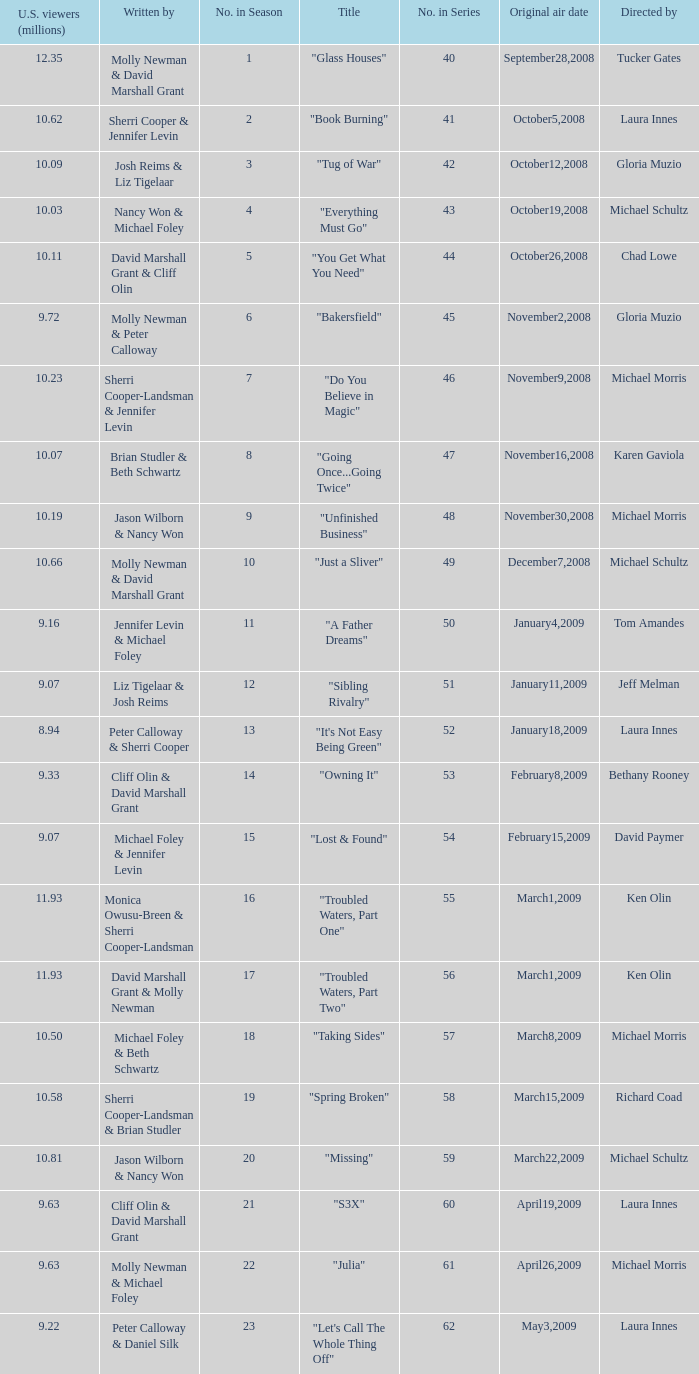Would you be able to parse every entry in this table? {'header': ['U.S. viewers (millions)', 'Written by', 'No. in Season', 'Title', 'No. in Series', 'Original air date', 'Directed by'], 'rows': [['12.35', 'Molly Newman & David Marshall Grant', '1', '"Glass Houses"', '40', 'September28,2008', 'Tucker Gates'], ['10.62', 'Sherri Cooper & Jennifer Levin', '2', '"Book Burning"', '41', 'October5,2008', 'Laura Innes'], ['10.09', 'Josh Reims & Liz Tigelaar', '3', '"Tug of War"', '42', 'October12,2008', 'Gloria Muzio'], ['10.03', 'Nancy Won & Michael Foley', '4', '"Everything Must Go"', '43', 'October19,2008', 'Michael Schultz'], ['10.11', 'David Marshall Grant & Cliff Olin', '5', '"You Get What You Need"', '44', 'October26,2008', 'Chad Lowe'], ['9.72', 'Molly Newman & Peter Calloway', '6', '"Bakersfield"', '45', 'November2,2008', 'Gloria Muzio'], ['10.23', 'Sherri Cooper-Landsman & Jennifer Levin', '7', '"Do You Believe in Magic"', '46', 'November9,2008', 'Michael Morris'], ['10.07', 'Brian Studler & Beth Schwartz', '8', '"Going Once...Going Twice"', '47', 'November16,2008', 'Karen Gaviola'], ['10.19', 'Jason Wilborn & Nancy Won', '9', '"Unfinished Business"', '48', 'November30,2008', 'Michael Morris'], ['10.66', 'Molly Newman & David Marshall Grant', '10', '"Just a Sliver"', '49', 'December7,2008', 'Michael Schultz'], ['9.16', 'Jennifer Levin & Michael Foley', '11', '"A Father Dreams"', '50', 'January4,2009', 'Tom Amandes'], ['9.07', 'Liz Tigelaar & Josh Reims', '12', '"Sibling Rivalry"', '51', 'January11,2009', 'Jeff Melman'], ['8.94', 'Peter Calloway & Sherri Cooper', '13', '"It\'s Not Easy Being Green"', '52', 'January18,2009', 'Laura Innes'], ['9.33', 'Cliff Olin & David Marshall Grant', '14', '"Owning It"', '53', 'February8,2009', 'Bethany Rooney'], ['9.07', 'Michael Foley & Jennifer Levin', '15', '"Lost & Found"', '54', 'February15,2009', 'David Paymer'], ['11.93', 'Monica Owusu-Breen & Sherri Cooper-Landsman', '16', '"Troubled Waters, Part One"', '55', 'March1,2009', 'Ken Olin'], ['11.93', 'David Marshall Grant & Molly Newman', '17', '"Troubled Waters, Part Two"', '56', 'March1,2009', 'Ken Olin'], ['10.50', 'Michael Foley & Beth Schwartz', '18', '"Taking Sides"', '57', 'March8,2009', 'Michael Morris'], ['10.58', 'Sherri Cooper-Landsman & Brian Studler', '19', '"Spring Broken"', '58', 'March15,2009', 'Richard Coad'], ['10.81', 'Jason Wilborn & Nancy Won', '20', '"Missing"', '59', 'March22,2009', 'Michael Schultz'], ['9.63', 'Cliff Olin & David Marshall Grant', '21', '"S3X"', '60', 'April19,2009', 'Laura Innes'], ['9.63', 'Molly Newman & Michael Foley', '22', '"Julia"', '61', 'April26,2009', 'Michael Morris'], ['9.22', 'Peter Calloway & Daniel Silk', '23', '"Let\'s Call The Whole Thing Off"', '62', 'May3,2009', 'Laura Innes']]} What's the name of the episode seen by 9.63 millions of people in the US, whose director is Laura Innes? "S3X". 